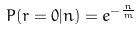Convert formula to latex. <formula><loc_0><loc_0><loc_500><loc_500>P ( r = 0 | n ) = e ^ { - \frac { n } { m } }</formula> 